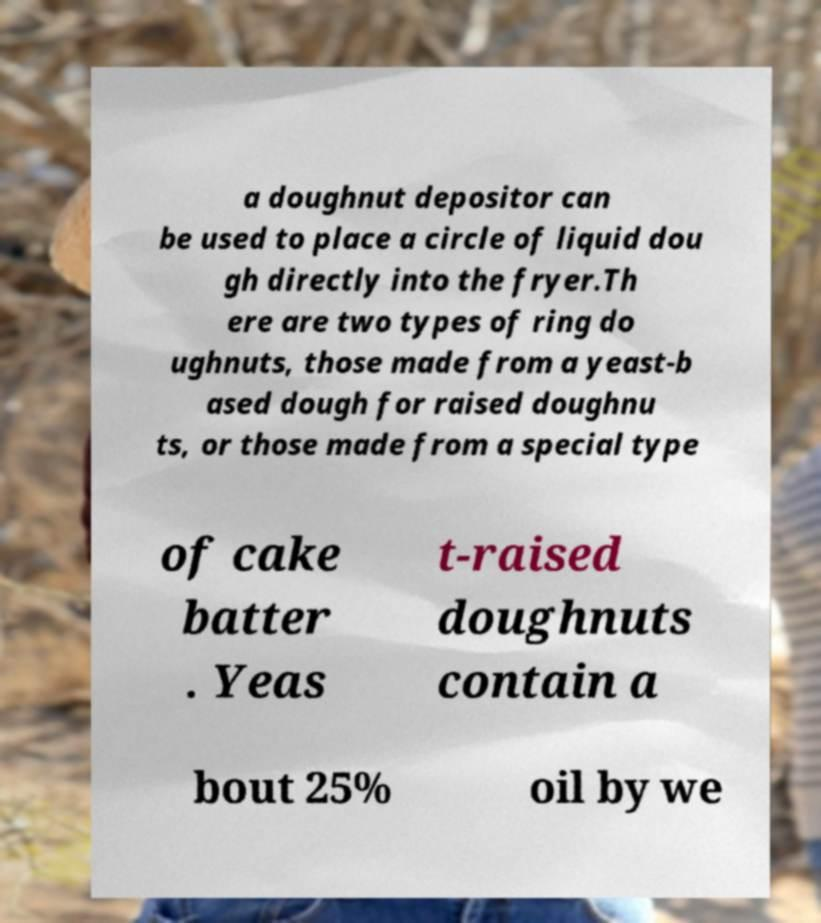Could you extract and type out the text from this image? a doughnut depositor can be used to place a circle of liquid dou gh directly into the fryer.Th ere are two types of ring do ughnuts, those made from a yeast-b ased dough for raised doughnu ts, or those made from a special type of cake batter . Yeas t-raised doughnuts contain a bout 25% oil by we 